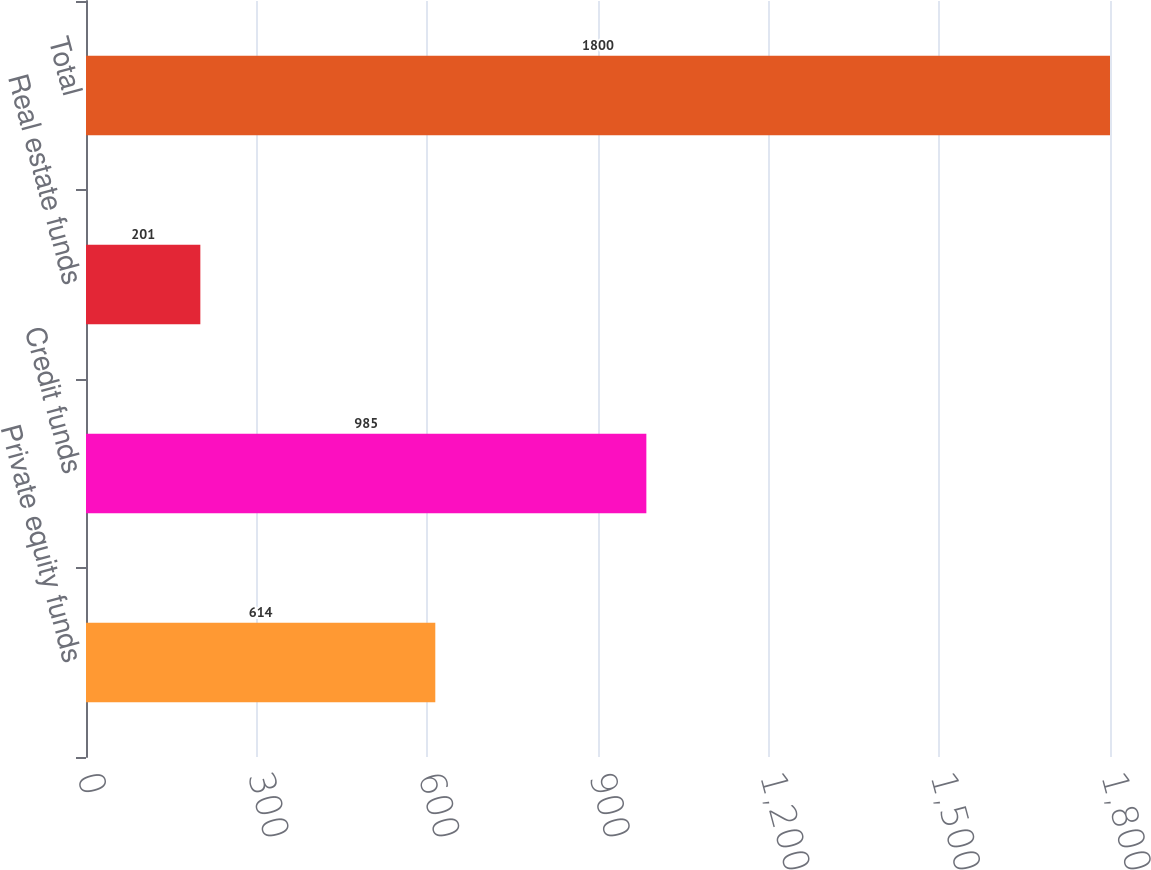Convert chart to OTSL. <chart><loc_0><loc_0><loc_500><loc_500><bar_chart><fcel>Private equity funds<fcel>Credit funds<fcel>Real estate funds<fcel>Total<nl><fcel>614<fcel>985<fcel>201<fcel>1800<nl></chart> 